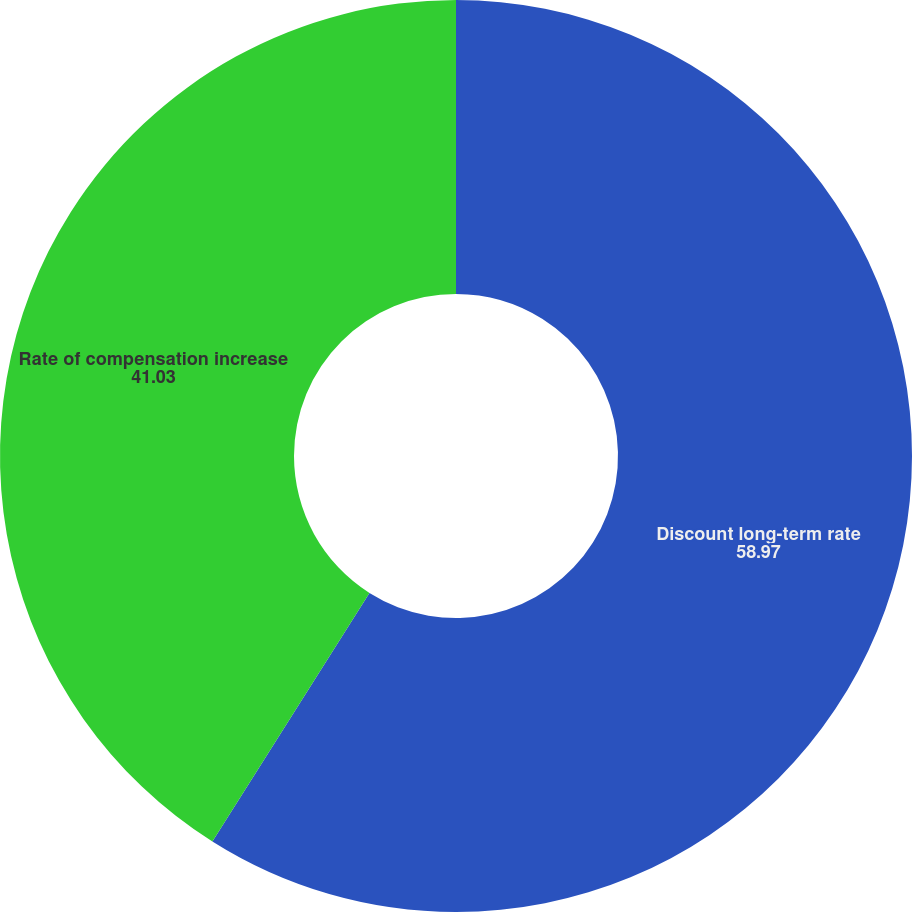Convert chart. <chart><loc_0><loc_0><loc_500><loc_500><pie_chart><fcel>Discount long-term rate<fcel>Rate of compensation increase<nl><fcel>58.97%<fcel>41.03%<nl></chart> 